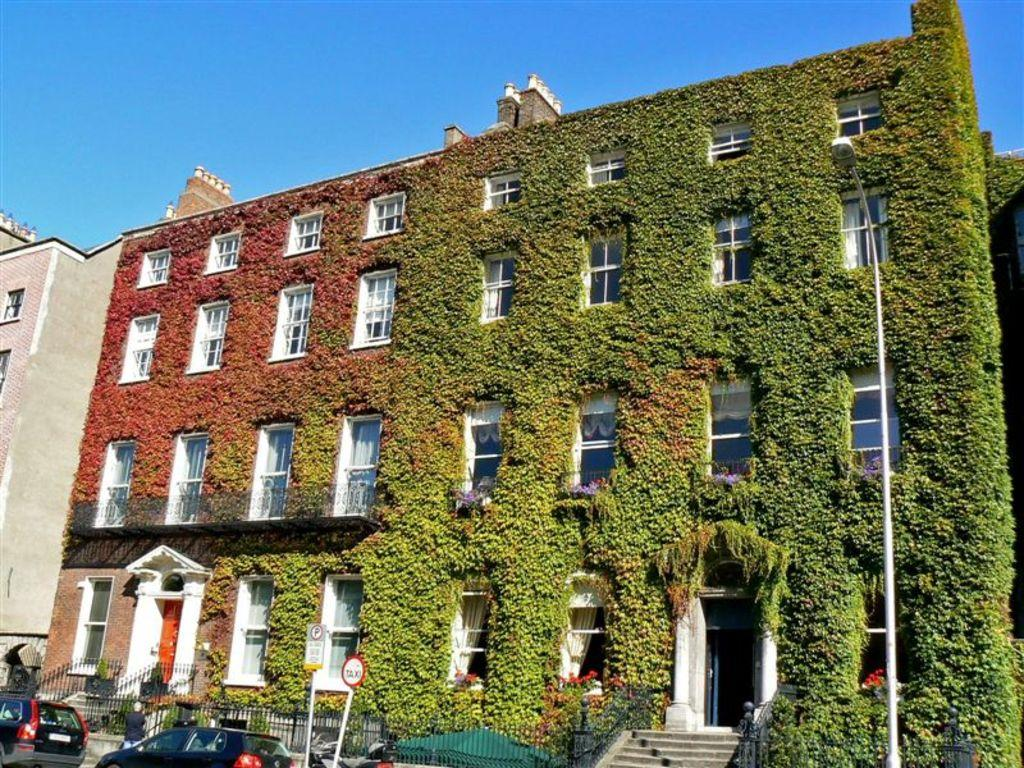What is the main subject of the image? The image depicts a building. Are there any plants visible on the building? Yes, there are green plants on the building. What can be seen on the left side of the image? There are cars on the left side of the image. What are the cars doing in the image? The cars are moving on the road. Can you tell me how many fish are swimming in the building's fountain in the image? There is no fountain or fish present in the image; it only features a building with green plants and cars on the left side. 